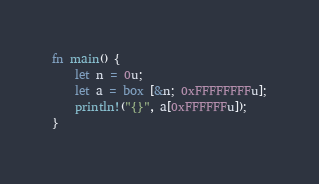<code> <loc_0><loc_0><loc_500><loc_500><_Rust_>fn main() {
    let n = 0u;
    let a = box [&n; 0xFFFFFFFFu];
    println!("{}", a[0xFFFFFFu]);
}
</code> 